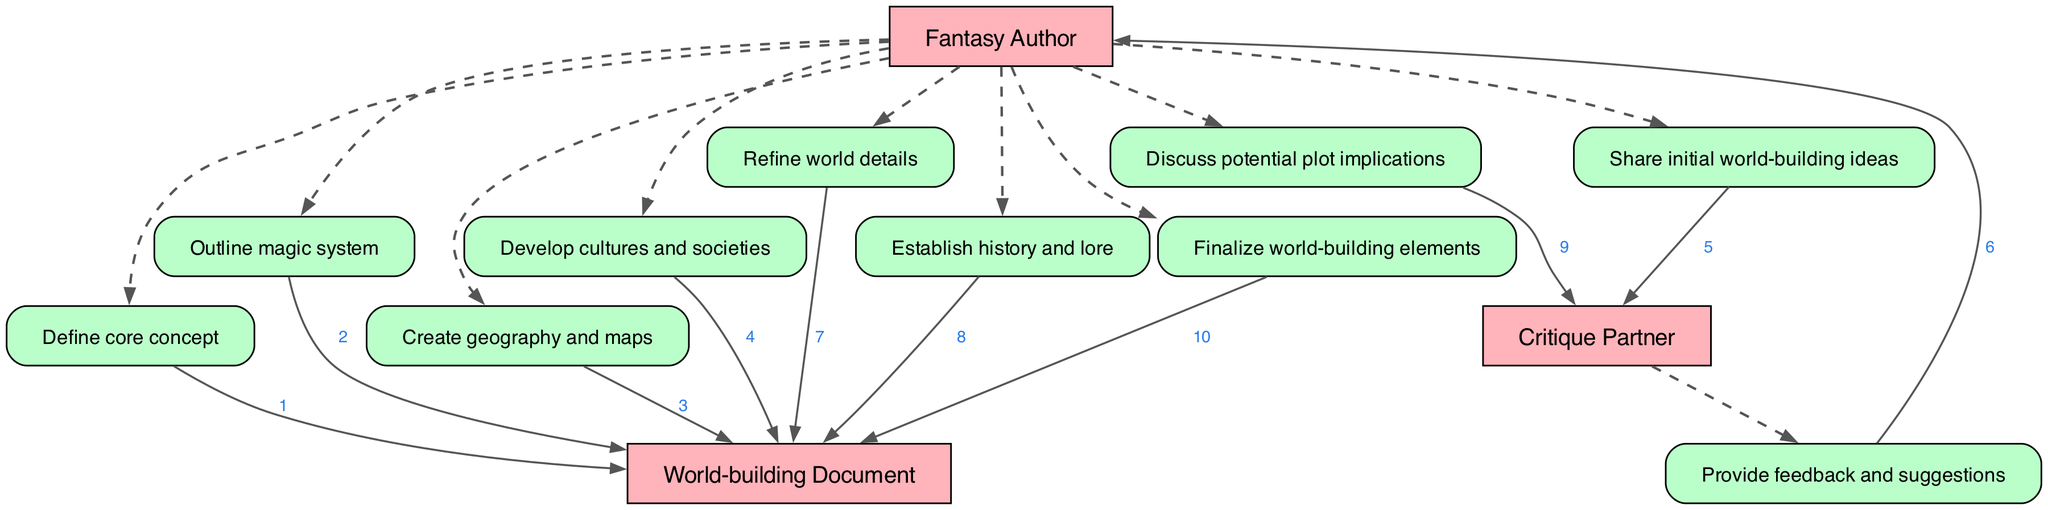What is the first action taken by the Fantasy Author? The first action taken by the Fantasy Author is to define the core concept of the world, as it is the first entry in the sequence of actions.
Answer: Define core concept How many primary actors are there in the diagram? The diagram lists three primary actors: the Fantasy Author, Critique Partner, and World-building Document, which can be counted directly from the actor list.
Answer: Three Which action follows the sharing of initial world-building ideas? After the Fantasy Author shares initial world-building ideas, the next step is for the Critique Partner to provide feedback and suggestions, as indicated by the sequence flow.
Answer: Provide feedback and suggestions What is the relationship between the Fantasy Author and the World-building Document? The Fantasy Author interacts with the World-building Document through various actions, where the Author is both defining and refining content within the document, indicating a direct working relationship.
Answer: Working relationship How many times does the Critique Partner interact with the Fantasy Author in the diagram? The Critique Partner interacts with the Fantasy Author twice: once to provide feedback and a second time to discuss potential plot implications, which can be identified from the arrows connecting them.
Answer: Twice Which action occurs right before the finalization of world-building elements? Before the finalization of world-building elements, the Fantasy Author establishes history and lore, as seen by tracing the sequence of actions leading up to that final step.
Answer: Establish history and lore What document is created after outlining the magic system? After outlining the magic system, the next action taken is to create geography and maps, showing a progression of world-building steps reflected in the actions.
Answer: Create geography and maps What is the last action listed in the sequence? The last action listed in the sequence is the finalization of world-building elements, which is at the end of the sequence indicating the completion of all previous steps of world-building.
Answer: Finalize world-building elements 